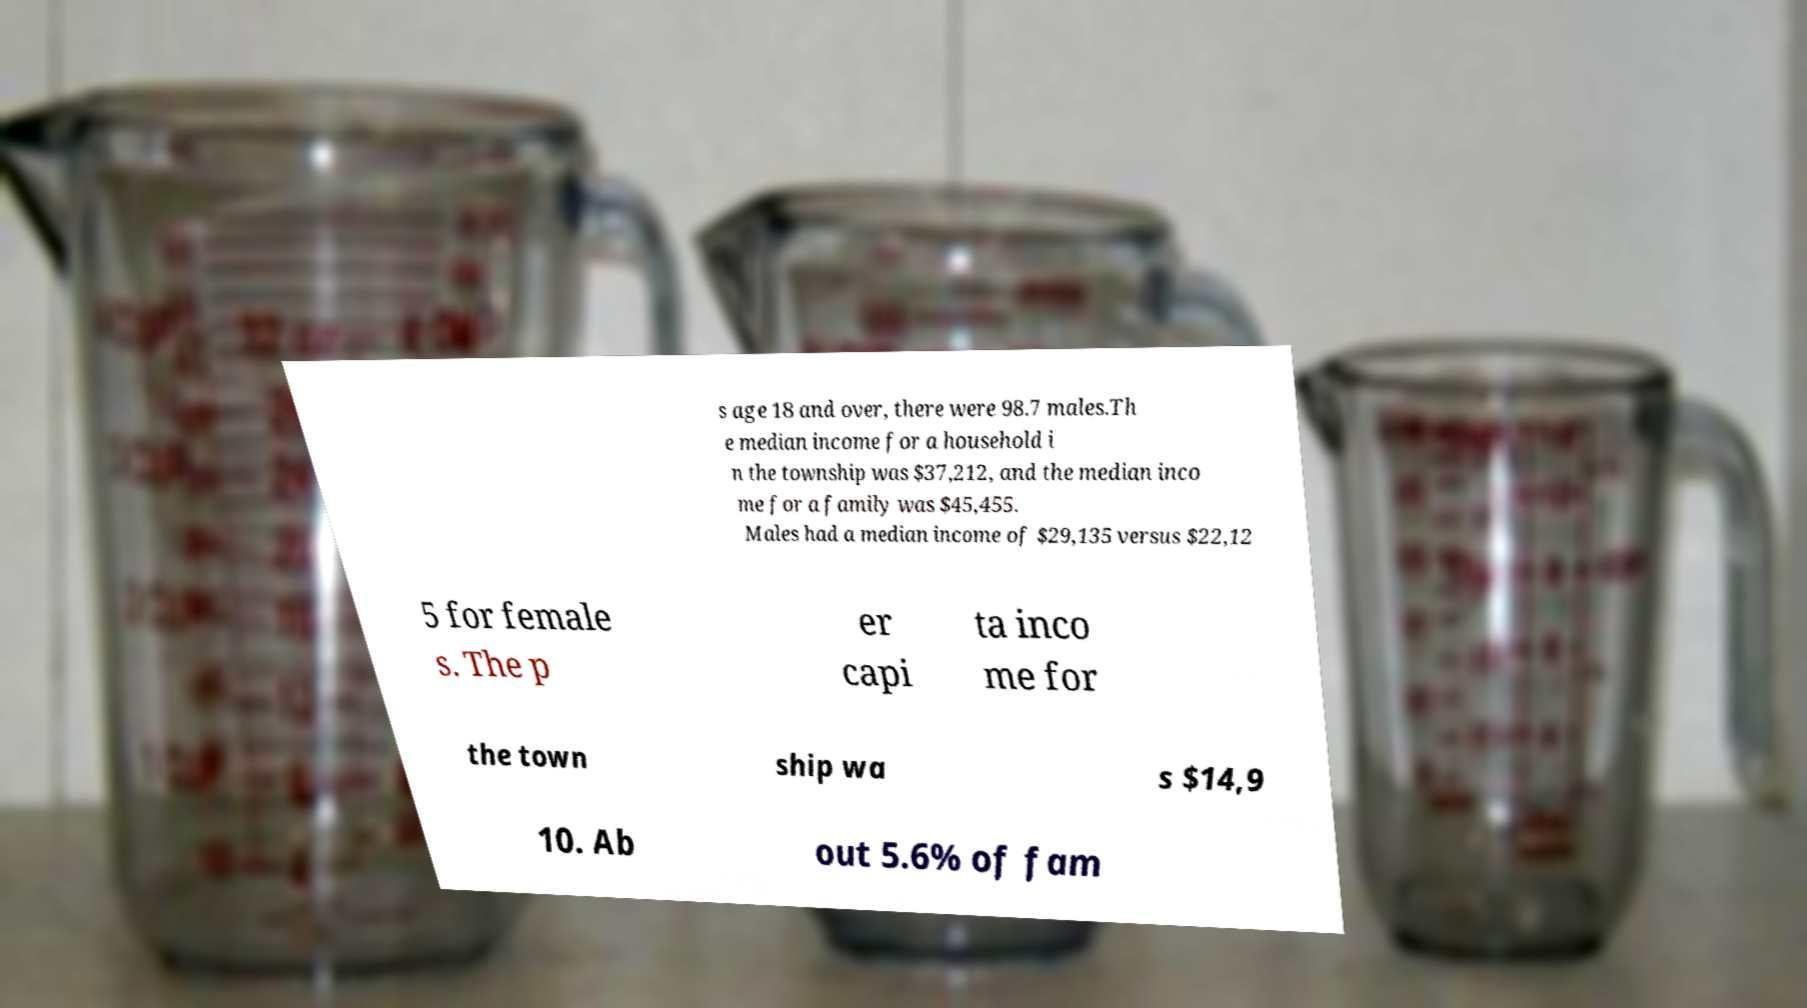Can you accurately transcribe the text from the provided image for me? s age 18 and over, there were 98.7 males.Th e median income for a household i n the township was $37,212, and the median inco me for a family was $45,455. Males had a median income of $29,135 versus $22,12 5 for female s. The p er capi ta inco me for the town ship wa s $14,9 10. Ab out 5.6% of fam 